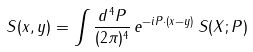<formula> <loc_0><loc_0><loc_500><loc_500>S ( x , y ) = \int \frac { d ^ { \, 4 } P } { ( 2 \pi ) ^ { 4 } } \, e ^ { - i P \cdot ( x - y ) } \, S ( X ; P )</formula> 